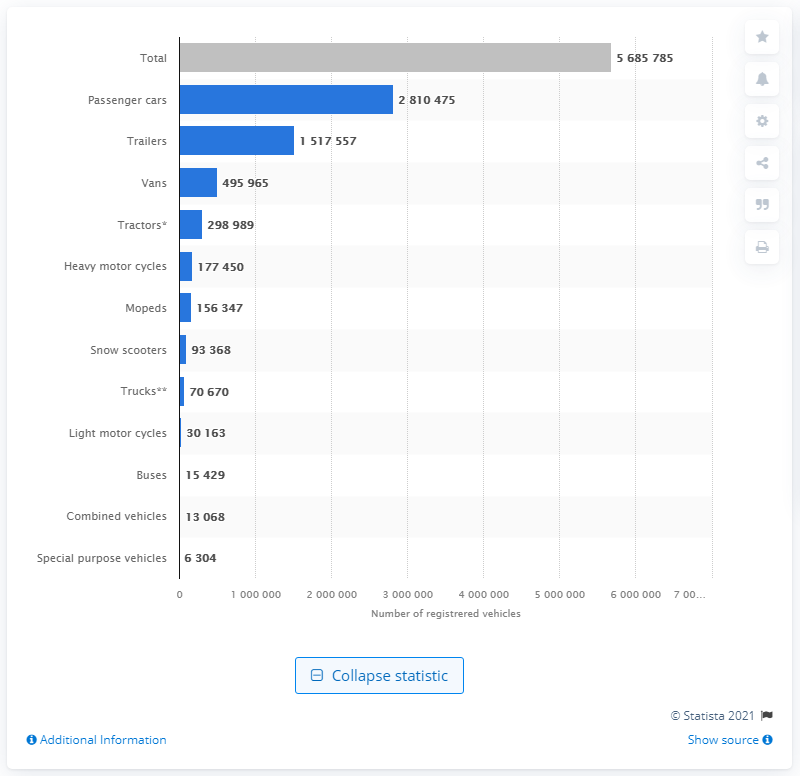Specify some key components in this picture. In 2020, there were a total of 281,047 passenger cars registered in Norway. 